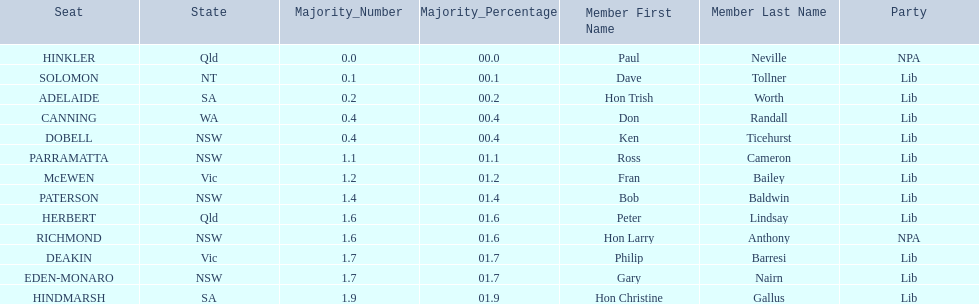Which seats are represented in the electoral system of australia? HINKLER, SOLOMON, ADELAIDE, CANNING, DOBELL, PARRAMATTA, McEWEN, PATERSON, HERBERT, RICHMOND, DEAKIN, EDEN-MONARO, HINDMARSH. What were their majority numbers of both hindmarsh and hinkler? HINKLER, HINDMARSH. Of those two seats, what is the difference in voting majority? 01.9. 